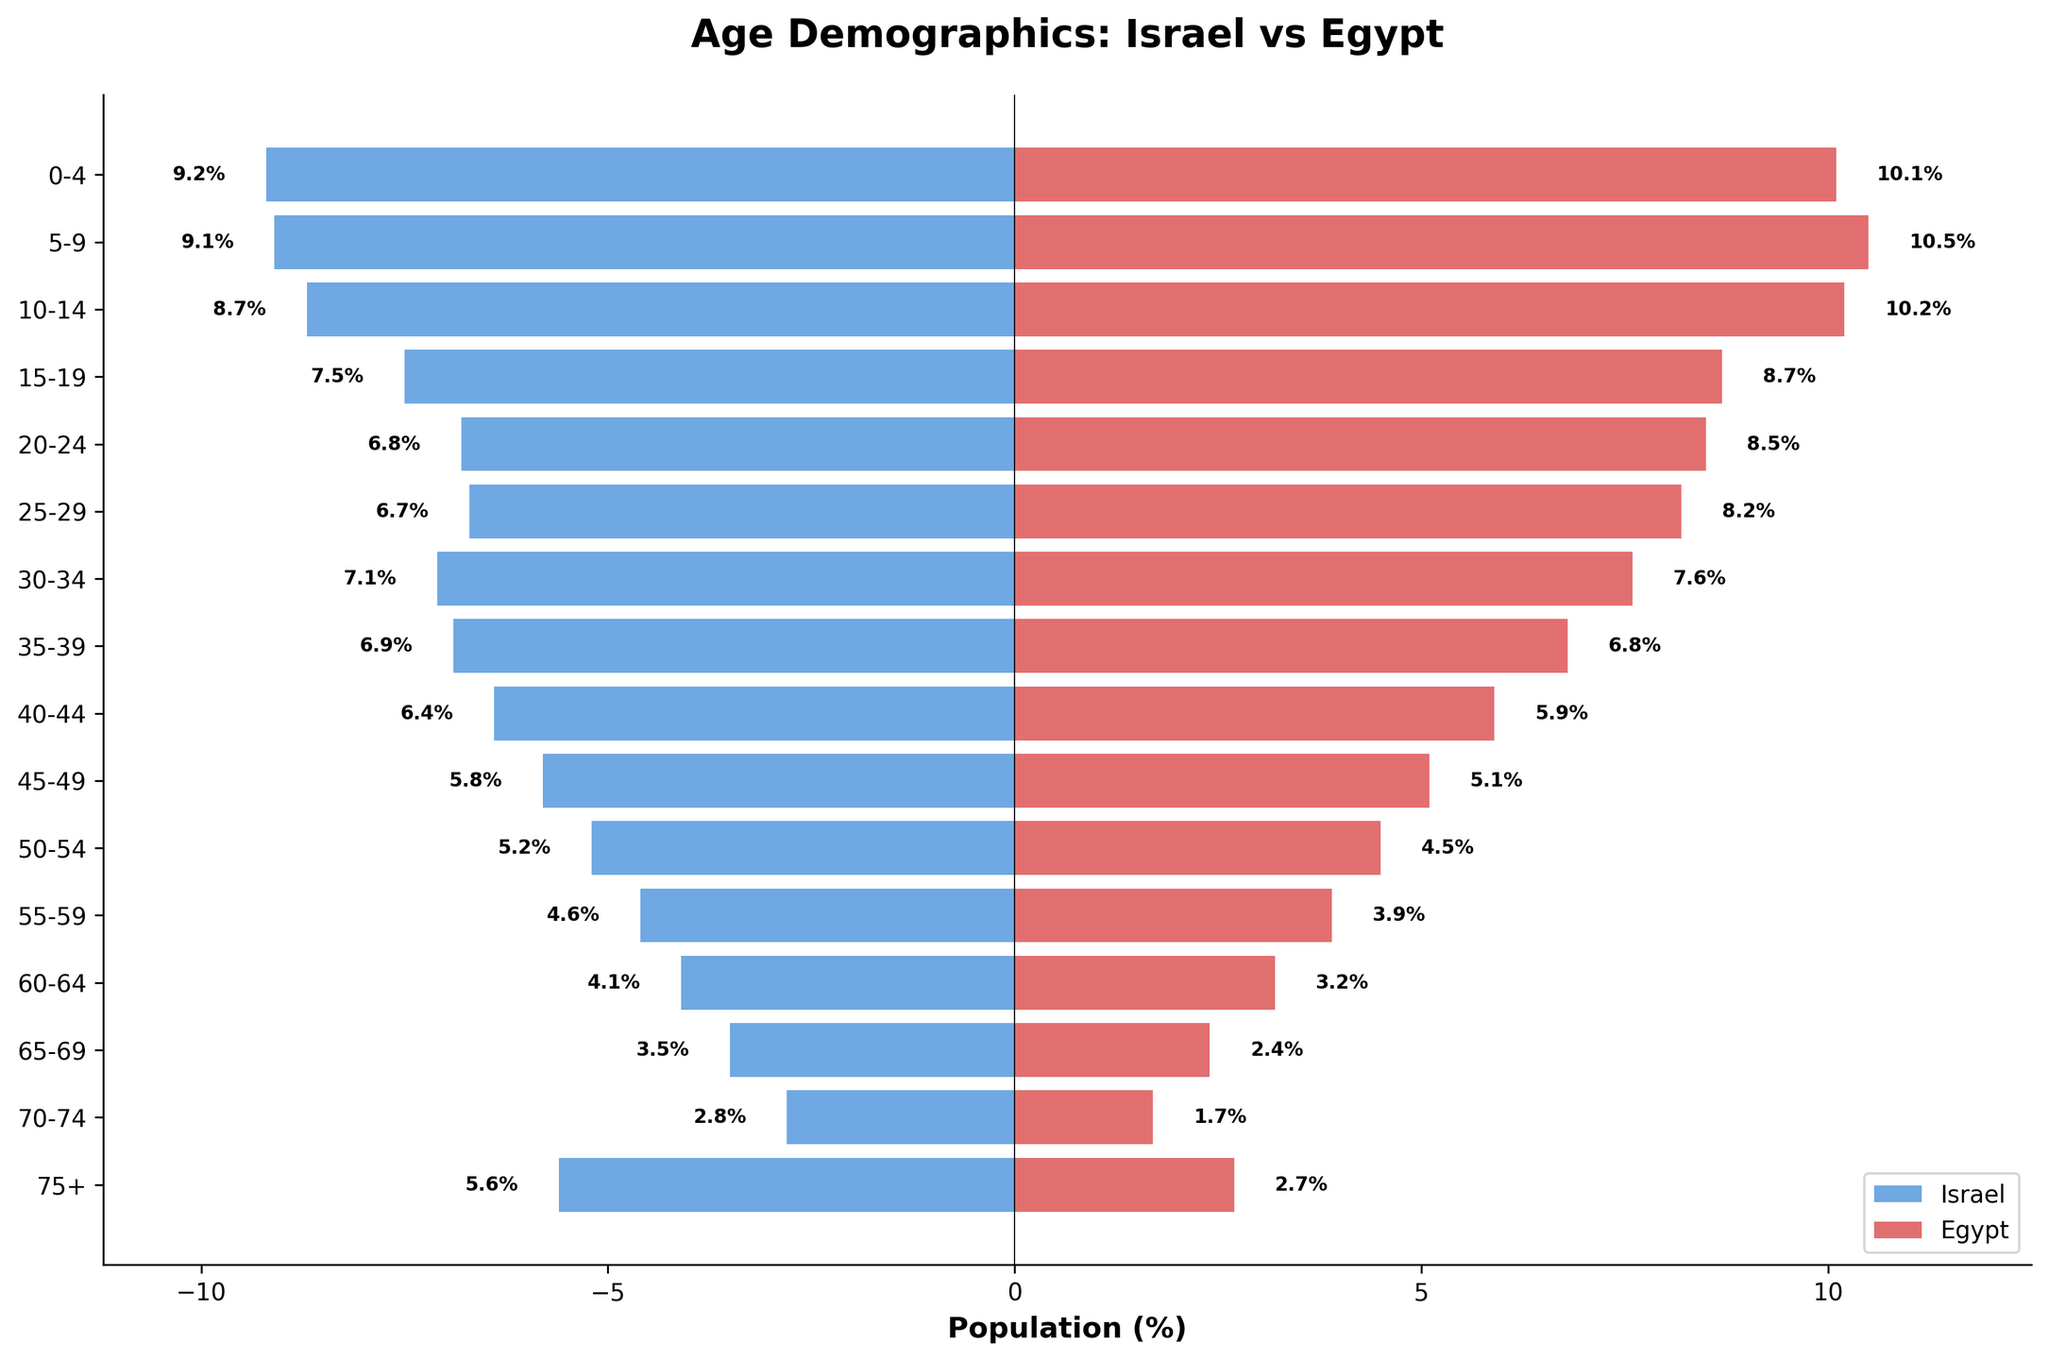What is the title of the figure? The title is typically located at the top of the plot. This figure has a title right above it that gives an overview of what the plot is about.
Answer: Age Demographics: Israel vs Egypt Which age group has the highest percentage in Egypt? To find this, look at the longest red bar on the right side of the pyramid under the Egypt section.
Answer: 5-9 What is the percentage of the 0-4 age group in Israel? Check the length of the bar corresponding to the 0-4 age group on the left side of the pyramid under Israel. The percentage shown near the bar is the value.
Answer: 9.2% How do the percentages for the 20-24 age group compare between the two countries? Look at the bars corresponding to the 20-24 age group for both Israel and Egypt. Compare the lengths of these bars. Israel is represented in blue and Egypt in red.
Answer: Israel: 6.8%, Egypt: 8.5% Which country has a higher percentage for the 65-69 age group? Look at the 65-69 bar on both sides. The side with the longer bar has the higher percentage.
Answer: Israel What is the difference in the percentage of the age group 75+ between Israel and Egypt? Subtract the percentage of Egypt for the 75+ age group from that of Israel. The values are at the end of the longest bars.
Answer: 5.6% - 2.7% = 2.9% What is the combined percentage of the 15-19 and 20-24 age groups in Israel? Add the percentages of the 15-19 age group and the 20-24 age group from the Israel side.
Answer: 7.5% + 6.8% = 14.3% Which age group has almost equal percentages in both countries? Scan the bars from top to bottom to find an age group where the blue and red bars are nearly the same length.
Answer: 35-39 What is the median age group in terms of percentage for Egypt? To find the median, list all age groups with their percentages and find the one in the middle. For Egypt, sort and find the 8th value in an ordered list of percentages.
Answer: 40-44 In which country do the younger age groups (0-14) make up a higher percentage of the population? Sum the percentages of the 0-4, 5-9, and 10-14 age groups for both countries. Compare these sums to determine which is higher.
Answer: Egypt 